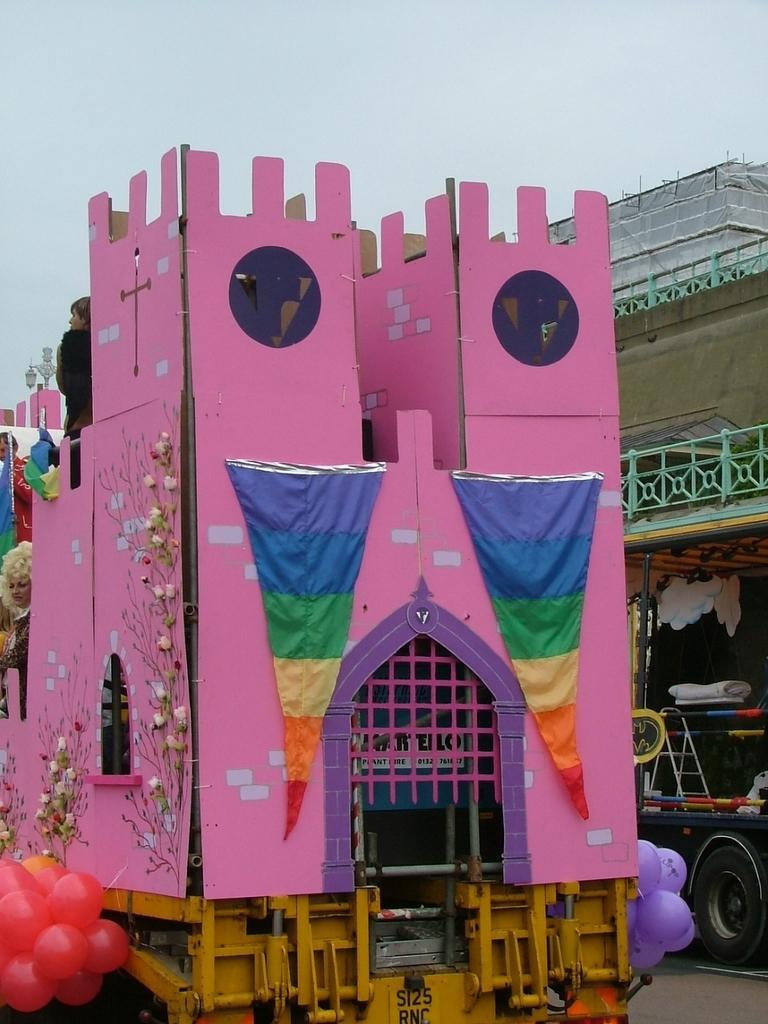How would you summarize this image in a sentence or two? In this image, we can see a building models on vehicles. There are balloons in the bottom left of the image. There is a sky at the top of the image. 